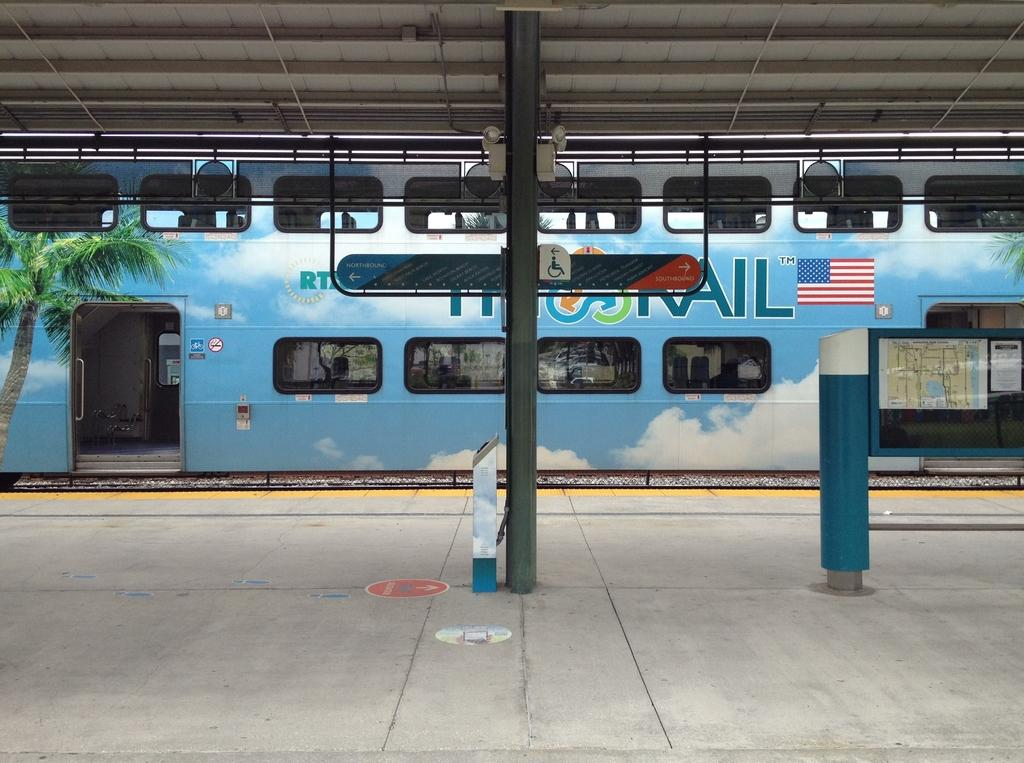What is the main structure visible in the image? There is a platform in the image. What is located near the platform? There is a pole in the image. What can be seen through the windows in the image? The windows in the image provide a view of the surroundings. What is on the track in the image? There is a train on the track in the image. What time of day is it in the image? The image is taken during the day. What type of bedroom can be seen in the image? There is no bedroom present in the image; it features a platform, pole, windows, train, and the time of day. Are there any police officers visible in the image? There are no police officers present in the image. 